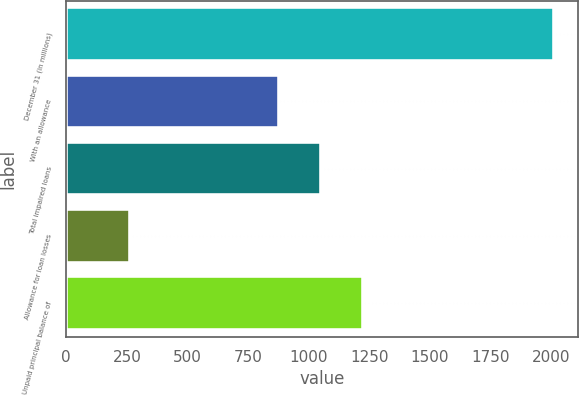Convert chart to OTSL. <chart><loc_0><loc_0><loc_500><loc_500><bar_chart><fcel>December 31 (in millions)<fcel>With an allowance<fcel>Total impaired loans<fcel>Allowance for loan losses<fcel>Unpaid principal balance of<nl><fcel>2010<fcel>876<fcel>1050.6<fcel>264<fcel>1225.2<nl></chart> 